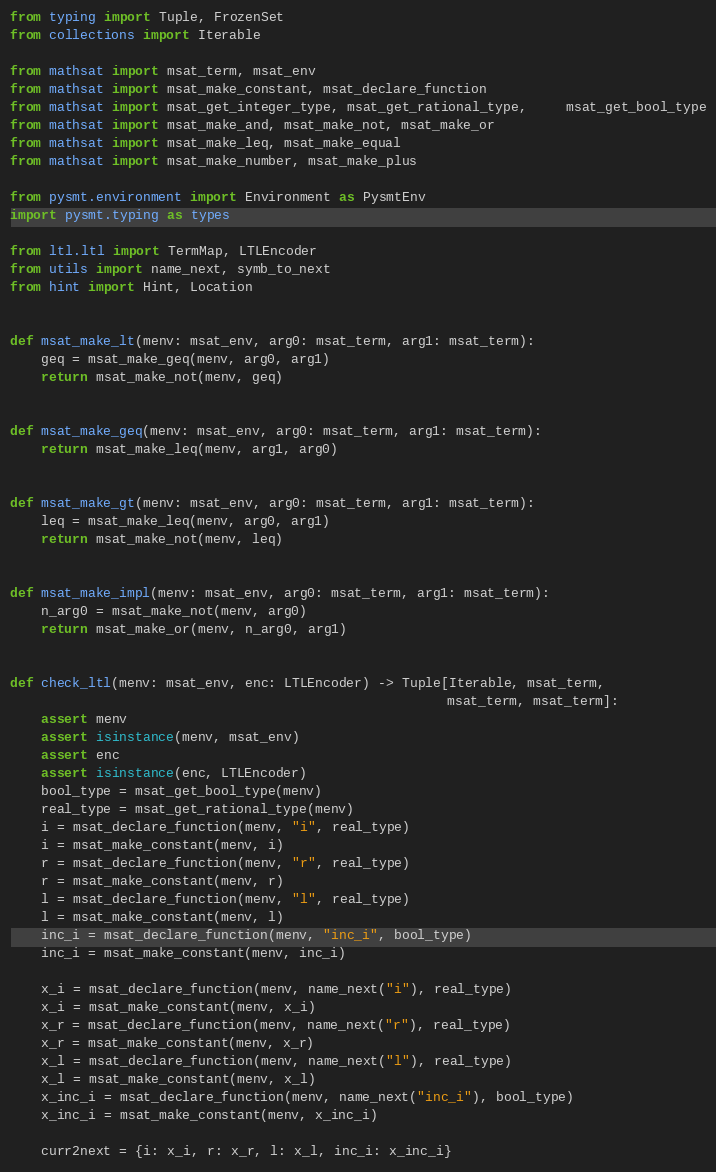Convert code to text. <code><loc_0><loc_0><loc_500><loc_500><_Python_>from typing import Tuple, FrozenSet
from collections import Iterable

from mathsat import msat_term, msat_env
from mathsat import msat_make_constant, msat_declare_function
from mathsat import msat_get_integer_type, msat_get_rational_type,     msat_get_bool_type
from mathsat import msat_make_and, msat_make_not, msat_make_or
from mathsat import msat_make_leq, msat_make_equal
from mathsat import msat_make_number, msat_make_plus

from pysmt.environment import Environment as PysmtEnv
import pysmt.typing as types

from ltl.ltl import TermMap, LTLEncoder
from utils import name_next, symb_to_next
from hint import Hint, Location


def msat_make_lt(menv: msat_env, arg0: msat_term, arg1: msat_term):
    geq = msat_make_geq(menv, arg0, arg1)
    return msat_make_not(menv, geq)


def msat_make_geq(menv: msat_env, arg0: msat_term, arg1: msat_term):
    return msat_make_leq(menv, arg1, arg0)


def msat_make_gt(menv: msat_env, arg0: msat_term, arg1: msat_term):
    leq = msat_make_leq(menv, arg0, arg1)
    return msat_make_not(menv, leq)


def msat_make_impl(menv: msat_env, arg0: msat_term, arg1: msat_term):
    n_arg0 = msat_make_not(menv, arg0)
    return msat_make_or(menv, n_arg0, arg1)


def check_ltl(menv: msat_env, enc: LTLEncoder) -> Tuple[Iterable, msat_term,
                                                        msat_term, msat_term]:
    assert menv
    assert isinstance(menv, msat_env)
    assert enc
    assert isinstance(enc, LTLEncoder)
    bool_type = msat_get_bool_type(menv)
    real_type = msat_get_rational_type(menv)
    i = msat_declare_function(menv, "i", real_type)
    i = msat_make_constant(menv, i)
    r = msat_declare_function(menv, "r", real_type)
    r = msat_make_constant(menv, r)
    l = msat_declare_function(menv, "l", real_type)
    l = msat_make_constant(menv, l)
    inc_i = msat_declare_function(menv, "inc_i", bool_type)
    inc_i = msat_make_constant(menv, inc_i)

    x_i = msat_declare_function(menv, name_next("i"), real_type)
    x_i = msat_make_constant(menv, x_i)
    x_r = msat_declare_function(menv, name_next("r"), real_type)
    x_r = msat_make_constant(menv, x_r)
    x_l = msat_declare_function(menv, name_next("l"), real_type)
    x_l = msat_make_constant(menv, x_l)
    x_inc_i = msat_declare_function(menv, name_next("inc_i"), bool_type)
    x_inc_i = msat_make_constant(menv, x_inc_i)

    curr2next = {i: x_i, r: x_r, l: x_l, inc_i: x_inc_i}
</code> 